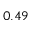Convert formula to latex. <formula><loc_0><loc_0><loc_500><loc_500>0 . 4 9</formula> 